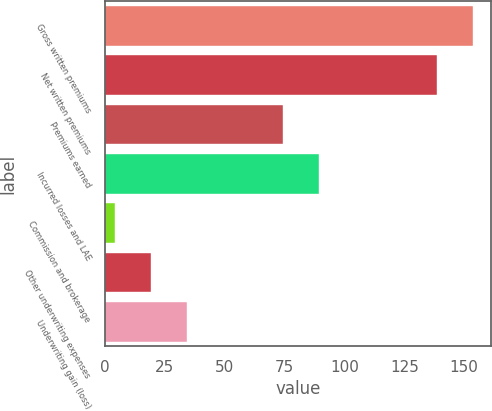Convert chart. <chart><loc_0><loc_0><loc_500><loc_500><bar_chart><fcel>Gross written premiums<fcel>Net written premiums<fcel>Premiums earned<fcel>Incurred losses and LAE<fcel>Commission and brokerage<fcel>Other underwriting expenses<fcel>Underwriting gain (loss)<nl><fcel>153.63<fcel>138.7<fcel>74.5<fcel>89.43<fcel>4.2<fcel>19.13<fcel>34.06<nl></chart> 